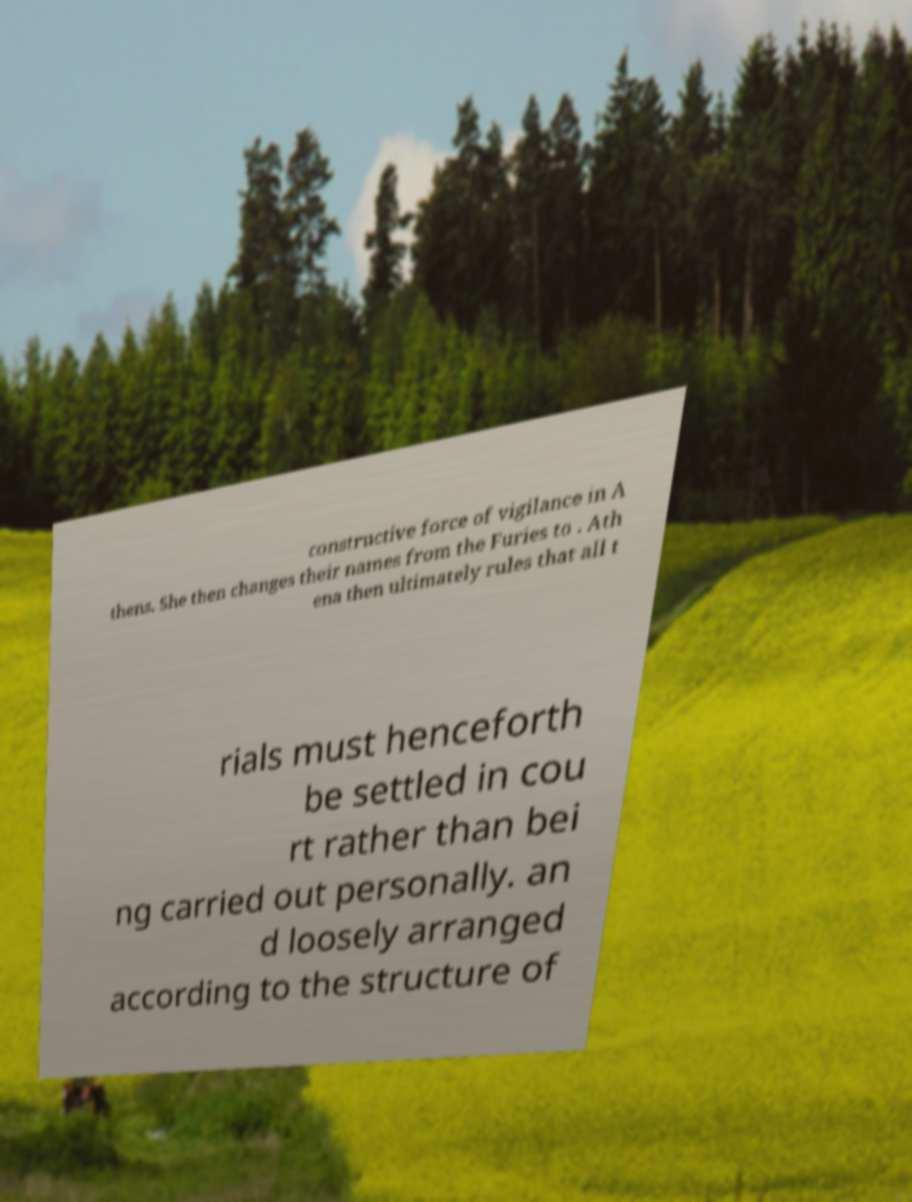There's text embedded in this image that I need extracted. Can you transcribe it verbatim? constructive force of vigilance in A thens. She then changes their names from the Furies to . Ath ena then ultimately rules that all t rials must henceforth be settled in cou rt rather than bei ng carried out personally. an d loosely arranged according to the structure of 